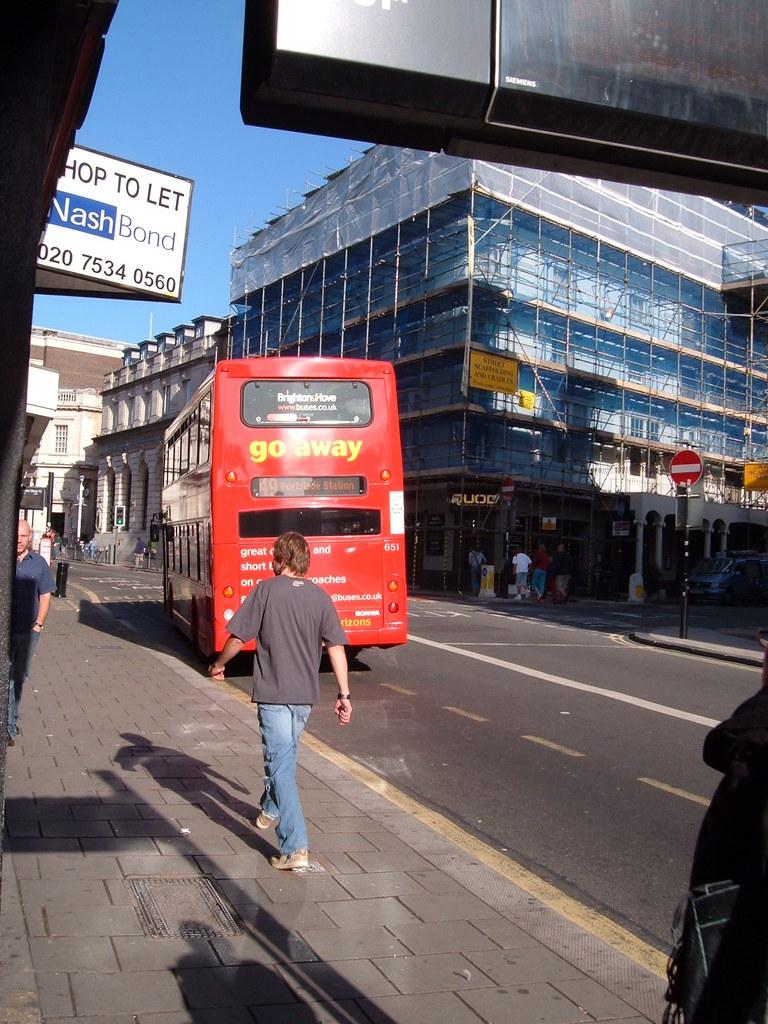What are the people in the image doing? The people in the image are walking on the road. What else can be seen on the road in the image? There are vehicles on the road in the image. What type of information might be conveyed by the sign boards in the image? The sign boards in the image might convey information about directions, rules, or advertisements. What are the poles in the image used for? The poles in the image might be used for supporting sign boards, wires, or street lights. What type of structures can be seen in the image? There are buildings in the image. What is the color of the sky in the image? The sky is blue in the image. Can you tell me how many monkeys are sitting on the roof of the building in the image? There are no monkeys present in the image; it only features people walking on the road, vehicles, sign boards, poles, buildings, and a blue sky. What type of oatmeal is being served at the restaurant in the image? There is no restaurant or oatmeal present in the image. 